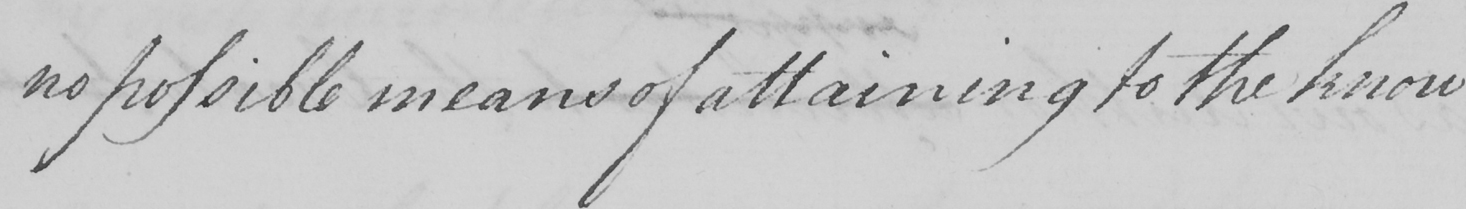Can you tell me what this handwritten text says? no possible means of attaining to the know 